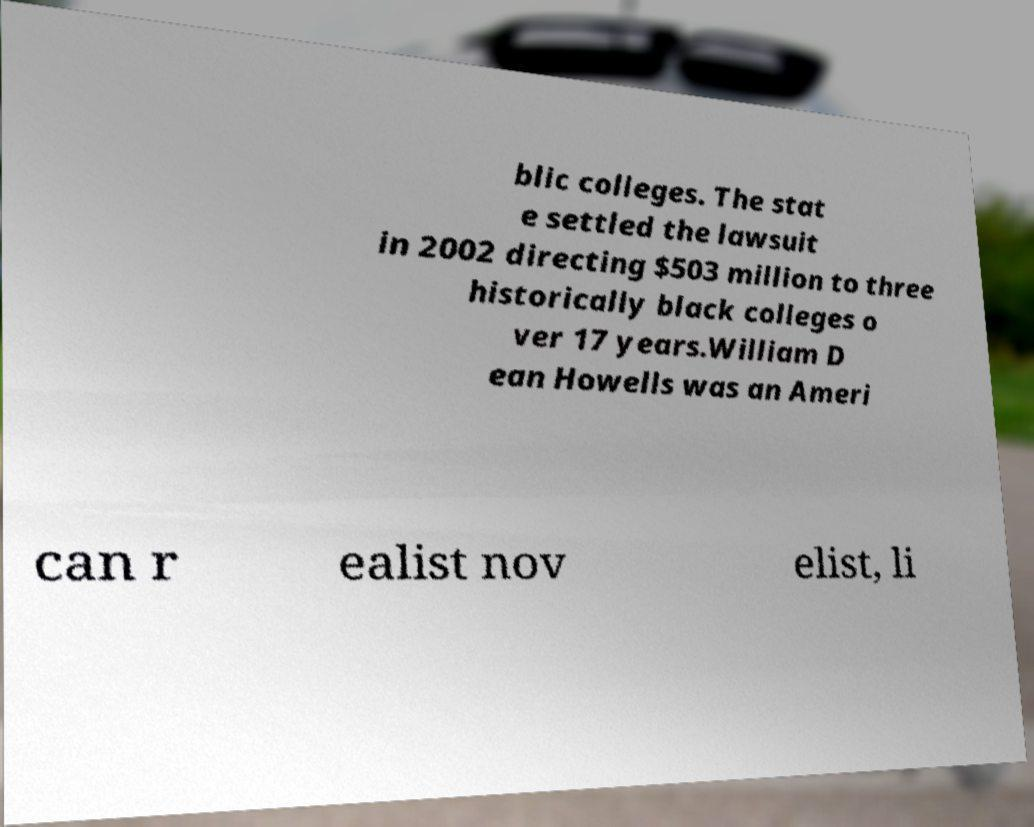What messages or text are displayed in this image? I need them in a readable, typed format. blic colleges. The stat e settled the lawsuit in 2002 directing $503 million to three historically black colleges o ver 17 years.William D ean Howells was an Ameri can r ealist nov elist, li 